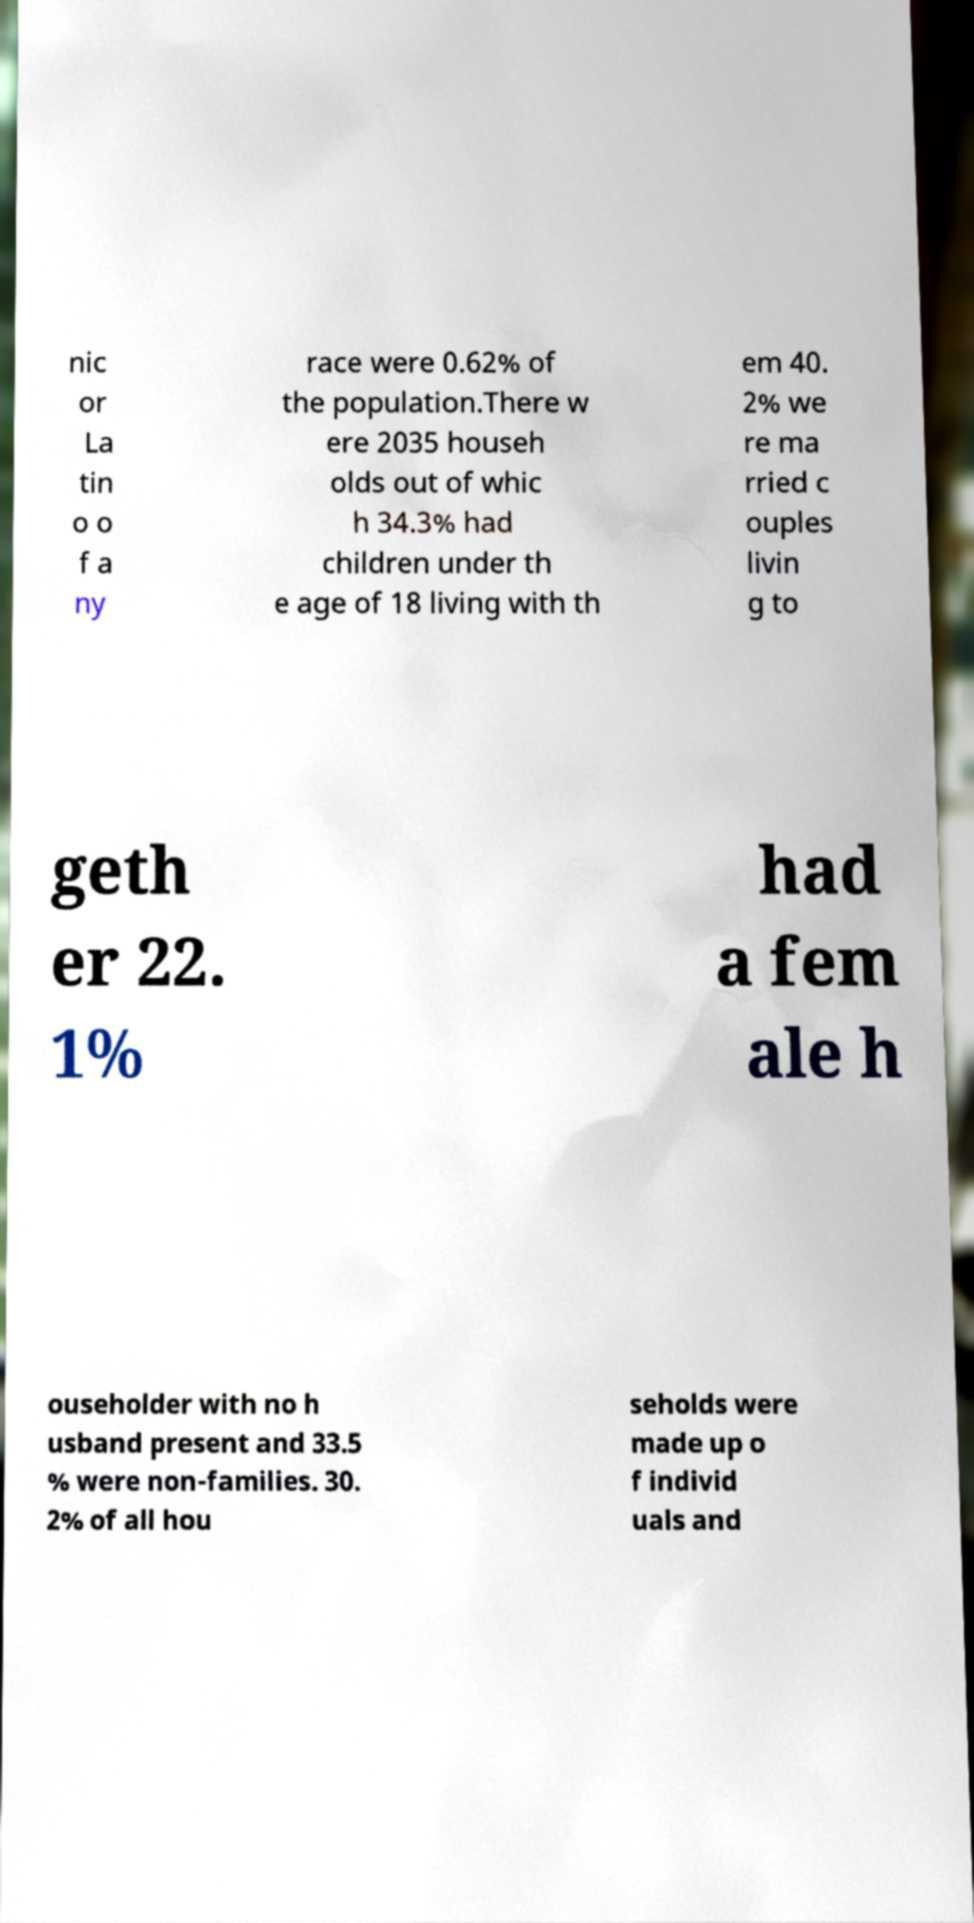What messages or text are displayed in this image? I need them in a readable, typed format. nic or La tin o o f a ny race were 0.62% of the population.There w ere 2035 househ olds out of whic h 34.3% had children under th e age of 18 living with th em 40. 2% we re ma rried c ouples livin g to geth er 22. 1% had a fem ale h ouseholder with no h usband present and 33.5 % were non-families. 30. 2% of all hou seholds were made up o f individ uals and 